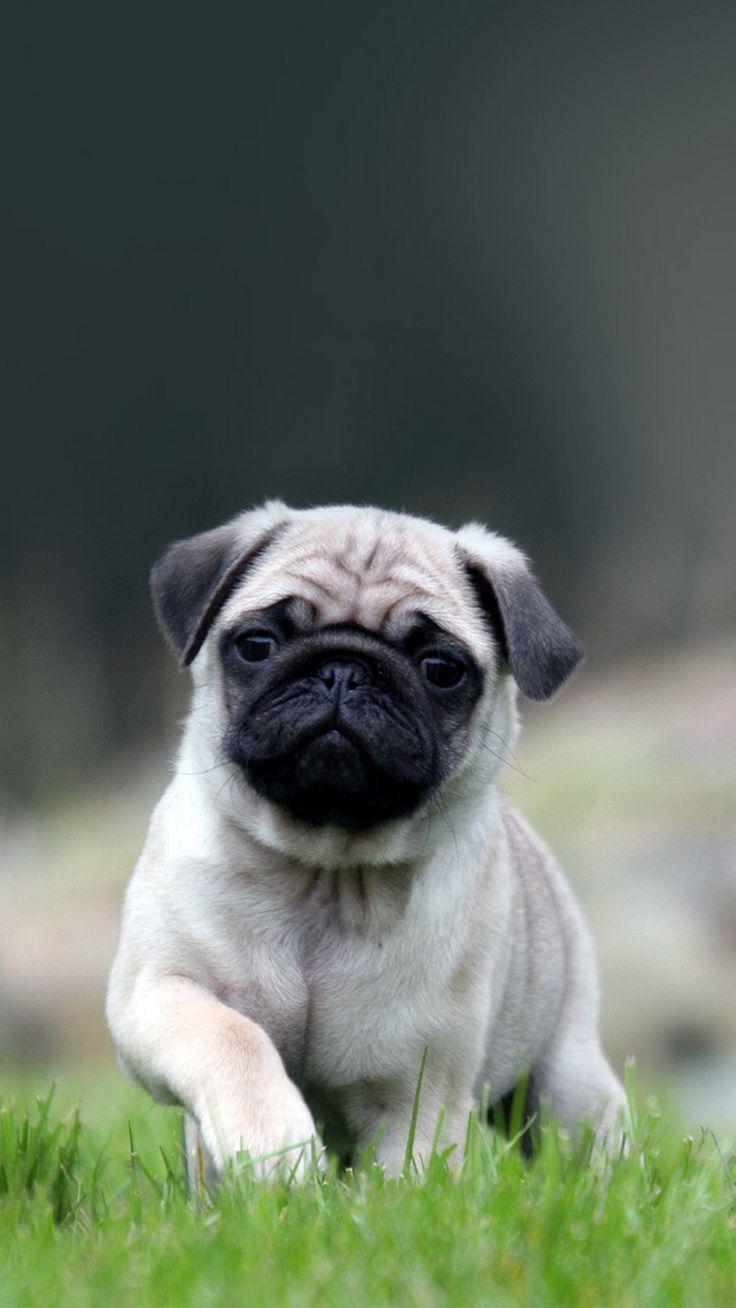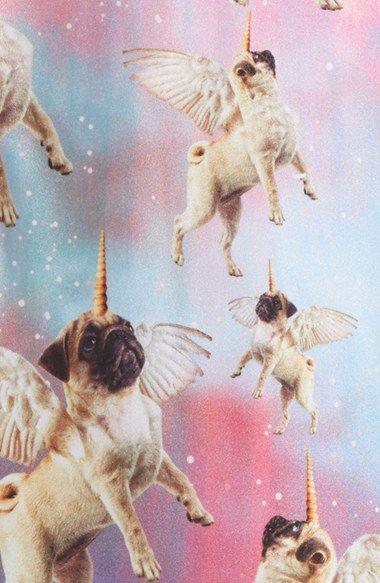The first image is the image on the left, the second image is the image on the right. Examine the images to the left and right. Is the description "At least one pug is wearing somehing on its neck." accurate? Answer yes or no. No. The first image is the image on the left, the second image is the image on the right. Assess this claim about the two images: "The left image shows one pug reclining on its belly with its front paws forward and its head upright.". Correct or not? Answer yes or no. No. 